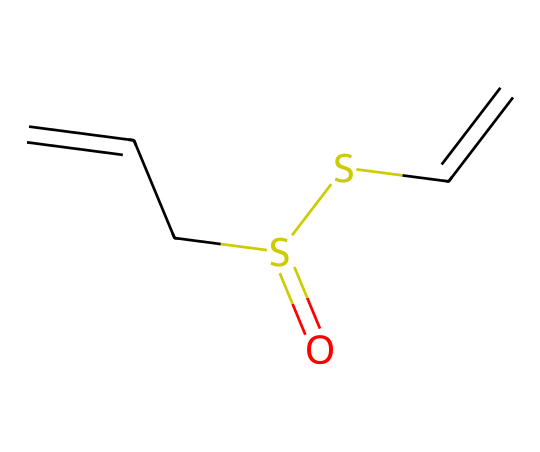What is the main functional group in allicin? The SMILES representation shows that there is a sulfur atom (S) connected to an oxygen atom (O) and carbon atoms, indicating a sulfoxide functionality. This determines the main functional group in allicin.
Answer: sulfoxide How many carbon atoms are present in the structure of allicin? By analyzing the SMILES, we can count the number of carbon atoms represented. There are 5 carbon atoms (C) in the structure of allicin.
Answer: 5 How many double bonds are present in allicin? In the provided SMILES, we can identify two double bonds between the carbon atoms (C=C). This indicates the total number of double bonds present in allicin.
Answer: 2 What type of compound is allicin classified as? Allicin, based on its sulfur-containing structure and characteristics, is classified as an organosulfur compound. This is due to the presence of sulfur as a part of the functional group.
Answer: organosulfur What bonds connect the sulfur atom to carbon in allicin? The structure shows that the sulfur atom is connected to carbon atoms through both single bonds and double bonds. This directly reflects typical bond types in organosulfur compounds.
Answer: single and double bonds How many sulfur atoms are in allicin? The SMILES representation includes one sulfur atom (S) in the entire structure, which confirms the total count of sulfur atoms in allicin.
Answer: 1 